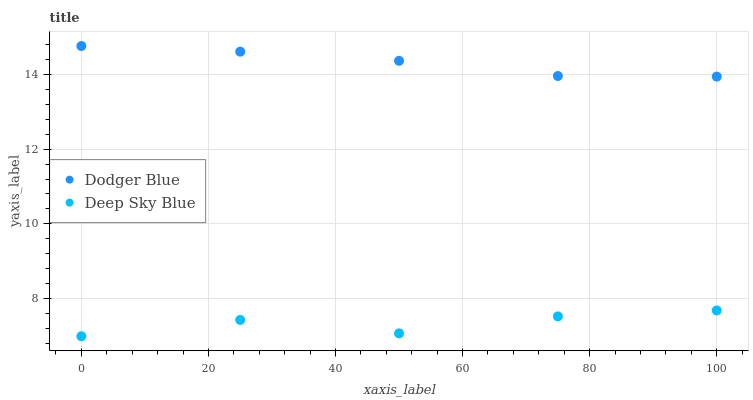Does Deep Sky Blue have the minimum area under the curve?
Answer yes or no. Yes. Does Dodger Blue have the maximum area under the curve?
Answer yes or no. Yes. Does Deep Sky Blue have the maximum area under the curve?
Answer yes or no. No. Is Dodger Blue the smoothest?
Answer yes or no. Yes. Is Deep Sky Blue the roughest?
Answer yes or no. Yes. Is Deep Sky Blue the smoothest?
Answer yes or no. No. Does Deep Sky Blue have the lowest value?
Answer yes or no. Yes. Does Dodger Blue have the highest value?
Answer yes or no. Yes. Does Deep Sky Blue have the highest value?
Answer yes or no. No. Is Deep Sky Blue less than Dodger Blue?
Answer yes or no. Yes. Is Dodger Blue greater than Deep Sky Blue?
Answer yes or no. Yes. Does Deep Sky Blue intersect Dodger Blue?
Answer yes or no. No. 